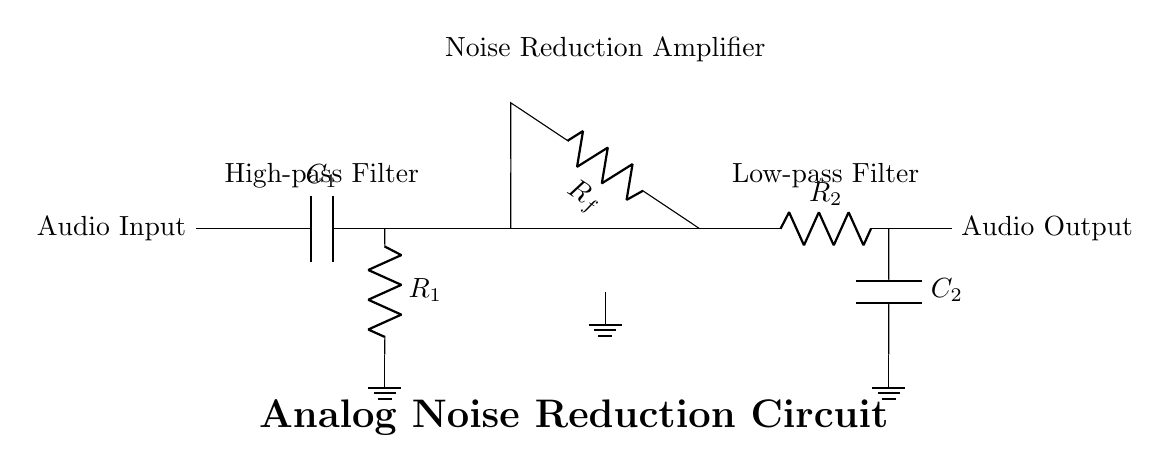What components are used in the noise reduction circuit? The circuit includes a capacitor (C1), two resistors (R1 and R2), a feedback resistor (R_f), a second capacitor (C2), and an operational amplifier. These components are essential for the high-pass and low-pass filtering stages as well as the amplification needed for noise reduction.
Answer: capacitor, resistor, operational amplifier What is the function of C1 in this circuit? C1 acts as a high-pass filter in conjunction with R1. This means it allows signals with frequencies higher than a certain cutoff frequency to pass while blocking lower frequencies, helping to reduce low-frequency noise before amplification.
Answer: high-pass filter Which component is responsible for the amplification in the circuit? The operational amplifier is designed to increase the amplitude of the audio signal, making it possible to process weak signals effectively. It is positioned after the high-pass filter to enhance the quality of the audio signal by reducing noise.
Answer: operational amplifier What does R_f do in the circuit? R_f is part of the feedback network in the operational amplifier configuration. Its value helps set the gain of the amplifier, which determines how much the input signal is amplified. This feedback ensures stability and minimizes distortion in the amplified output.
Answer: feedback resistor What is the purpose of the low-pass filter section in this circuit? The low-pass filter, consisting of R2 and C2, allows low-frequency signals to pass through while attenuating higher frequencies. This helps eliminate high-frequency noise that might still be present in the audio signal after amplification, contributing to overall noise reduction.
Answer: low-pass filter What type of filtering does R1 and C1 provide together? Together, R1 and C1 form a high-pass filter, which is specifically designed to block frequencies below a certain threshold while allowing higher frequencies to pass through, helping to maintain the integrity of the audio signal by reducing unwanted low-frequency noise.
Answer: high-pass filtering 